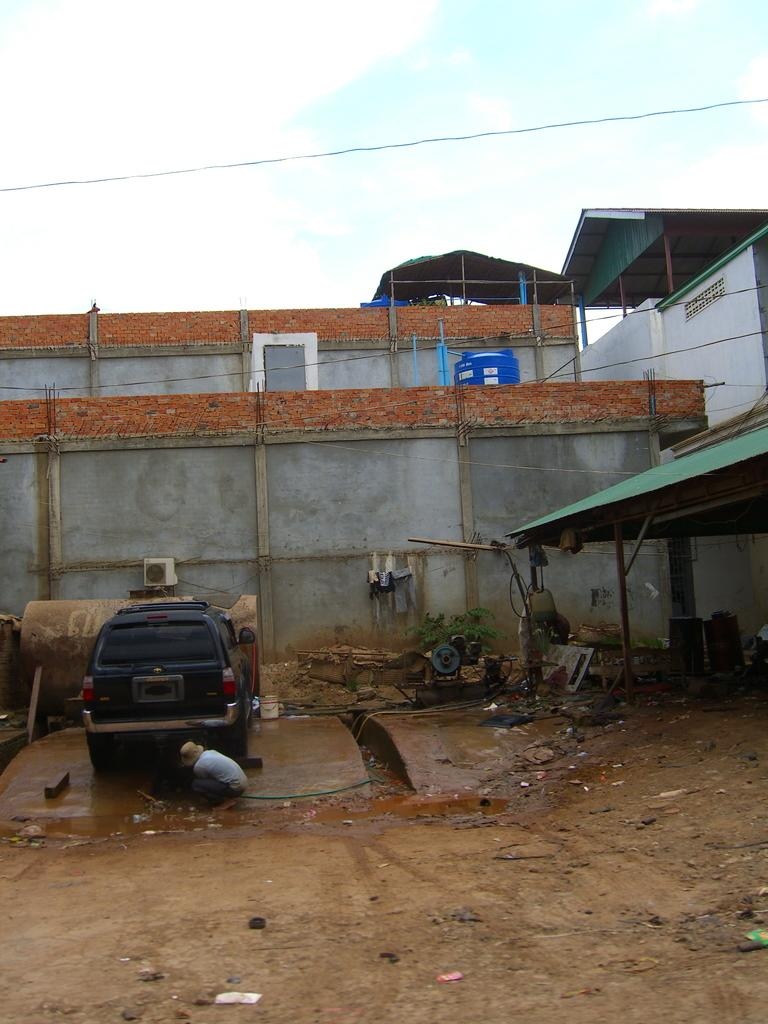What is the main subject in the image? There is a vehicle in the image. Can you describe the person in the image? There is a person on the ground in the image. What can be seen in the background of the image? There is a building and the sky visible in the background of the image. What color is the person's shirt in the image? There is no mention of a shirt in the image, as the person is on the ground and not wearing any visible clothing. 